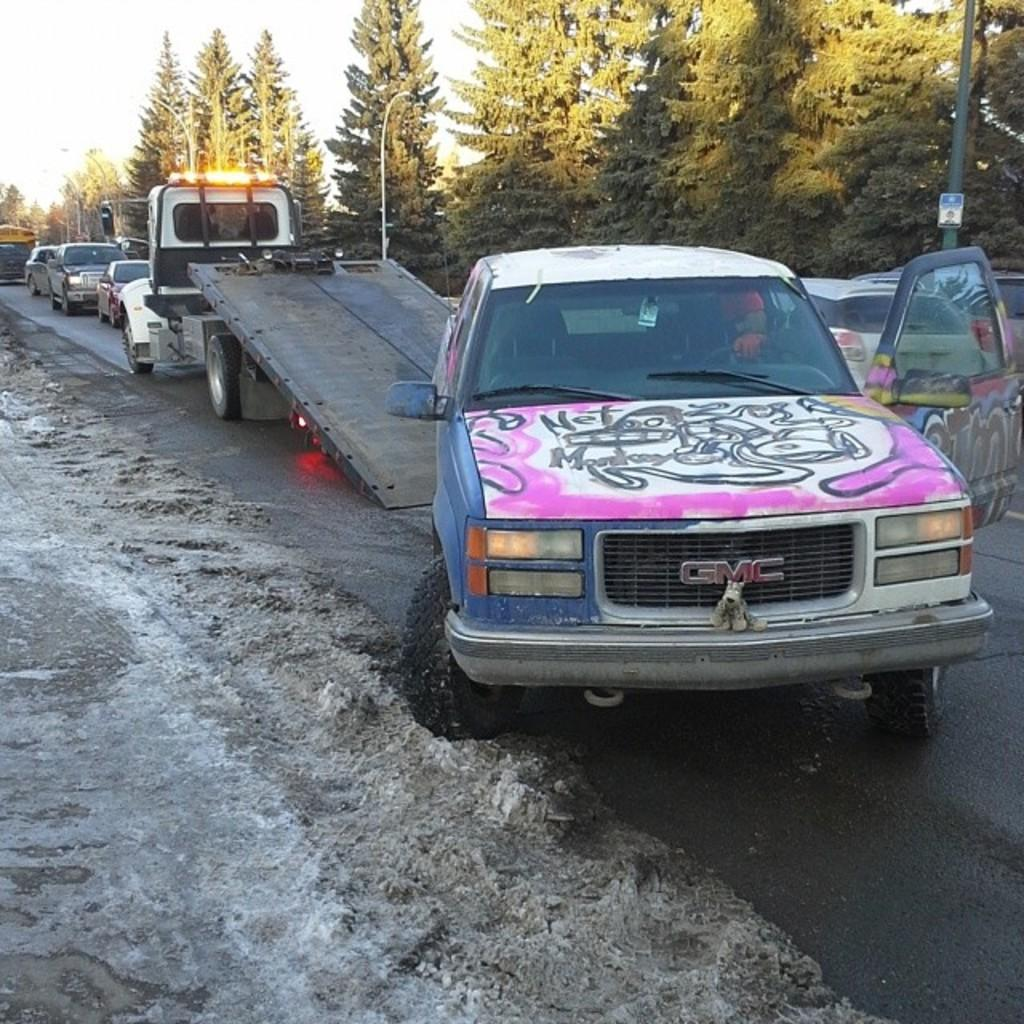What is happening to the car in the image? There is a car being towed onto a truck in the image. What else can be seen on the road in the image? There are other vehicles on the road in the image. What type of natural scenery is visible in the image? Trees are visible in the image. What type of birds can be seen perched on the twig in the image? There is no twig or birds present in the image. What is being served for dinner in the image? There is no dinner or indication of food in the image. 